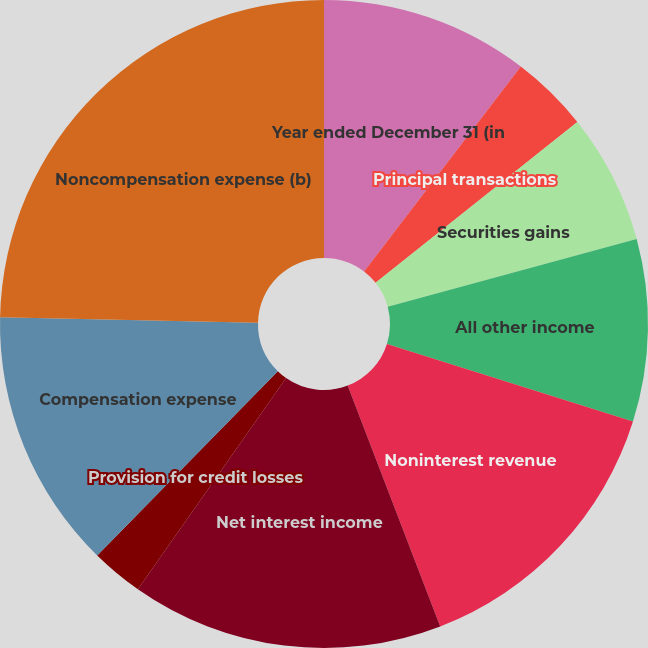Convert chart. <chart><loc_0><loc_0><loc_500><loc_500><pie_chart><fcel>Year ended December 31 (in<fcel>Principal transactions<fcel>Securities gains<fcel>All other income<fcel>Noninterest revenue<fcel>Net interest income<fcel>Total net revenue (a)<fcel>Provision for credit losses<fcel>Compensation expense<fcel>Noncompensation expense (b)<nl><fcel>10.39%<fcel>3.9%<fcel>6.49%<fcel>9.09%<fcel>14.29%<fcel>15.58%<fcel>0.0%<fcel>2.6%<fcel>12.99%<fcel>24.67%<nl></chart> 